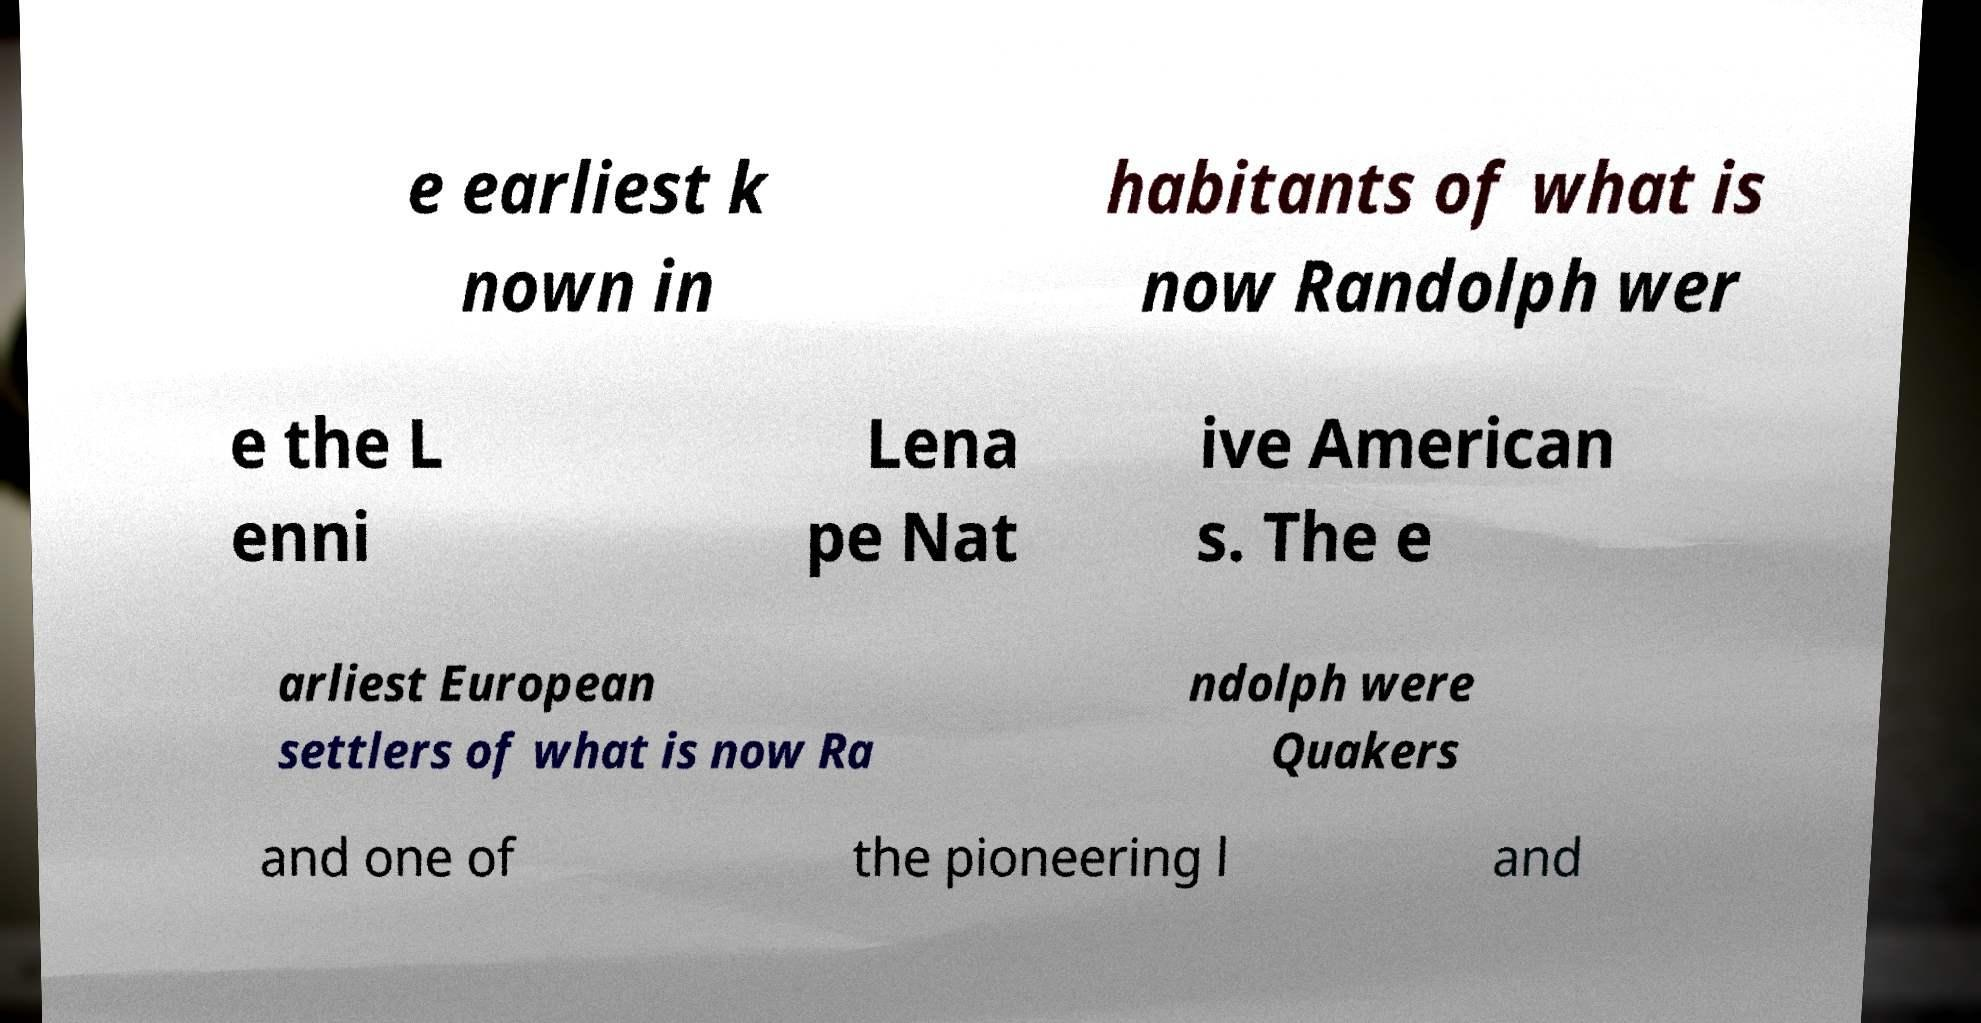Please identify and transcribe the text found in this image. e earliest k nown in habitants of what is now Randolph wer e the L enni Lena pe Nat ive American s. The e arliest European settlers of what is now Ra ndolph were Quakers and one of the pioneering l and 